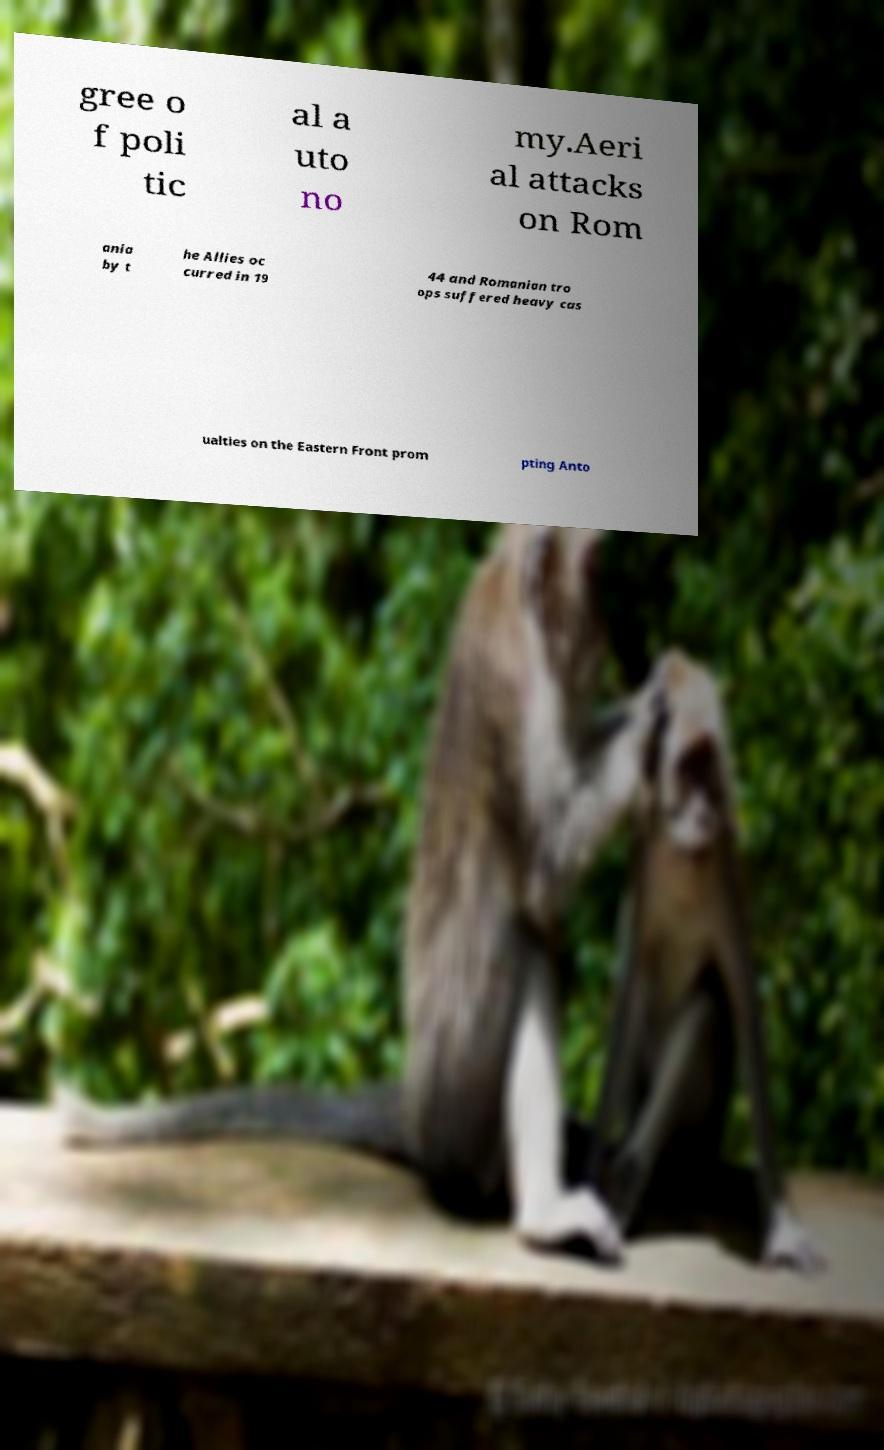Can you accurately transcribe the text from the provided image for me? gree o f poli tic al a uto no my.Aeri al attacks on Rom ania by t he Allies oc curred in 19 44 and Romanian tro ops suffered heavy cas ualties on the Eastern Front prom pting Anto 